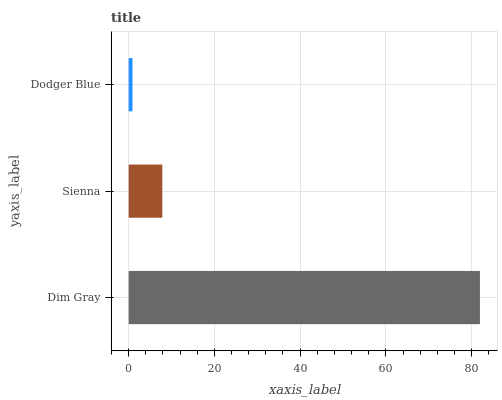Is Dodger Blue the minimum?
Answer yes or no. Yes. Is Dim Gray the maximum?
Answer yes or no. Yes. Is Sienna the minimum?
Answer yes or no. No. Is Sienna the maximum?
Answer yes or no. No. Is Dim Gray greater than Sienna?
Answer yes or no. Yes. Is Sienna less than Dim Gray?
Answer yes or no. Yes. Is Sienna greater than Dim Gray?
Answer yes or no. No. Is Dim Gray less than Sienna?
Answer yes or no. No. Is Sienna the high median?
Answer yes or no. Yes. Is Sienna the low median?
Answer yes or no. Yes. Is Dodger Blue the high median?
Answer yes or no. No. Is Dim Gray the low median?
Answer yes or no. No. 